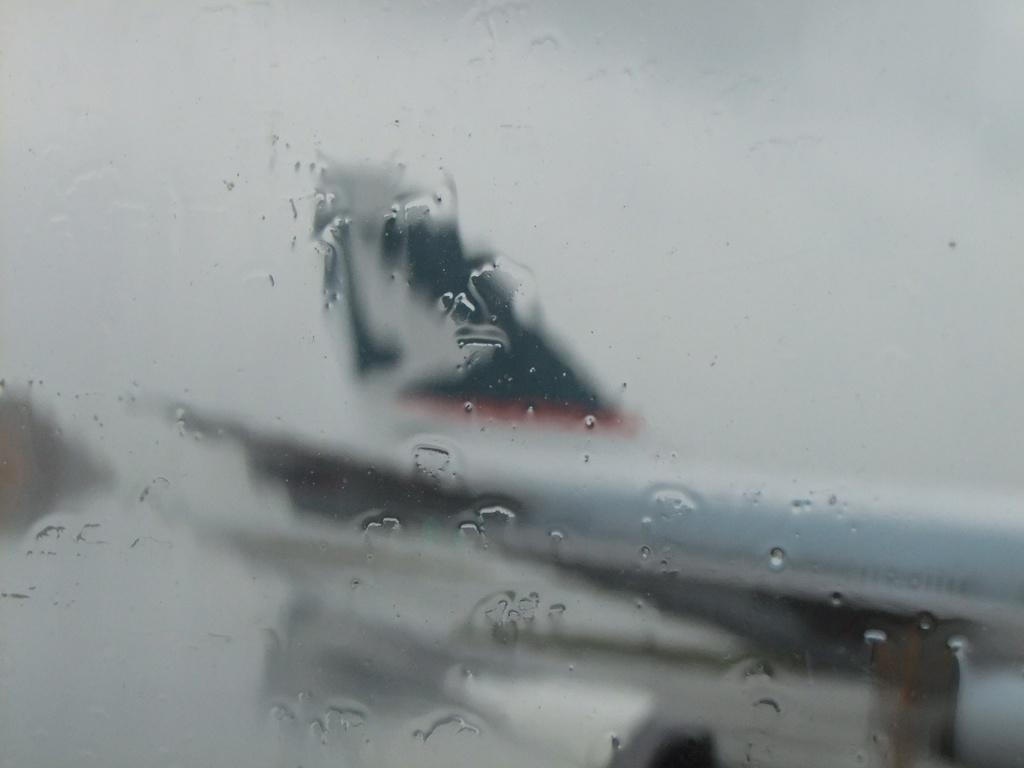What is the main subject of the image? The main subject of the image is an aeroplane reflection on a mirror. Can you describe the reflection in the image? The reflection in the image is of an aeroplane. How many tins are visible in the image? There are no tins present in the image; it features an aeroplane reflection on a mirror. How many legs does the aeroplane have in the image? The image is a reflection of an aeroplane, and aeroplanes do not have legs. 